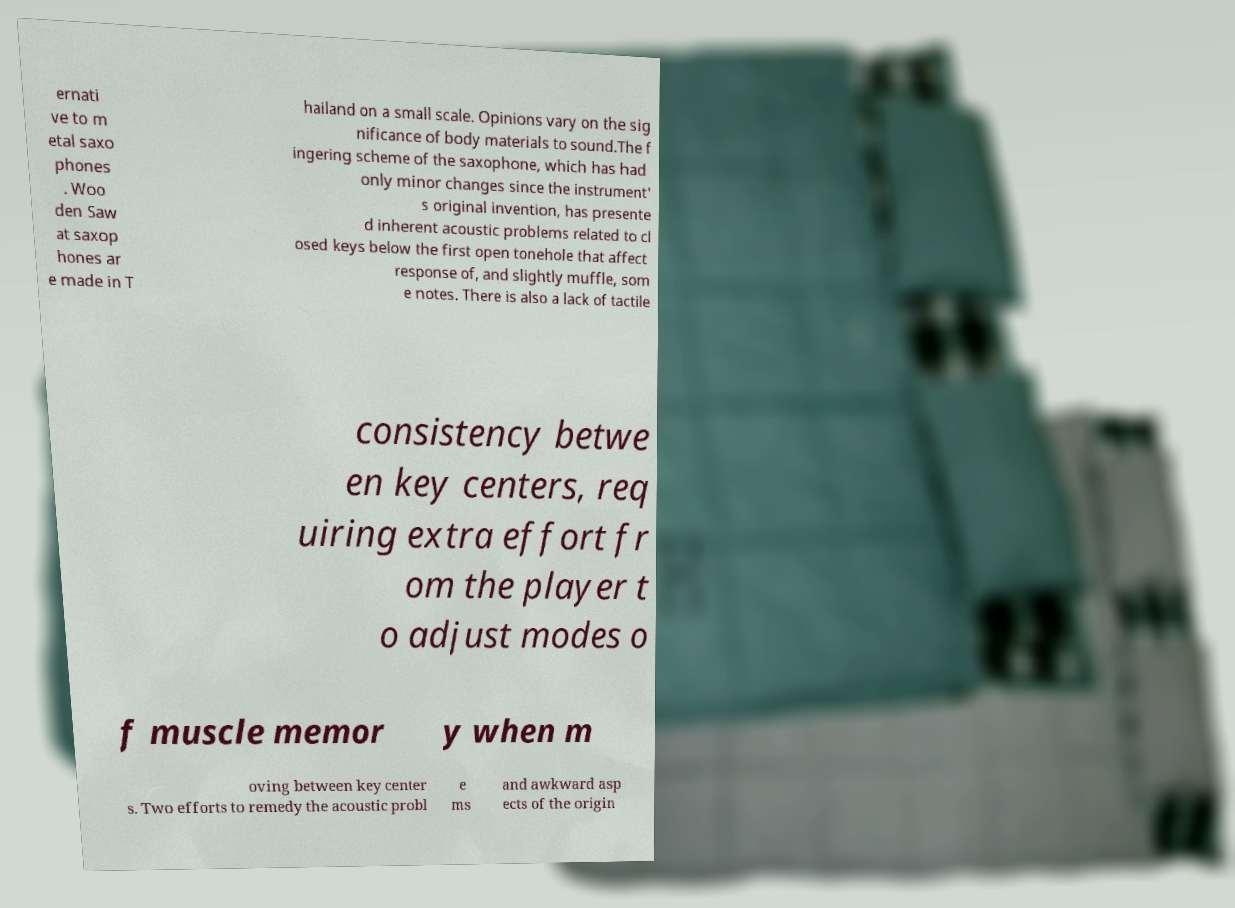Could you assist in decoding the text presented in this image and type it out clearly? ernati ve to m etal saxo phones . Woo den Saw at saxop hones ar e made in T hailand on a small scale. Opinions vary on the sig nificance of body materials to sound.The f ingering scheme of the saxophone, which has had only minor changes since the instrument' s original invention, has presente d inherent acoustic problems related to cl osed keys below the first open tonehole that affect response of, and slightly muffle, som e notes. There is also a lack of tactile consistency betwe en key centers, req uiring extra effort fr om the player t o adjust modes o f muscle memor y when m oving between key center s. Two efforts to remedy the acoustic probl e ms and awkward asp ects of the origin 